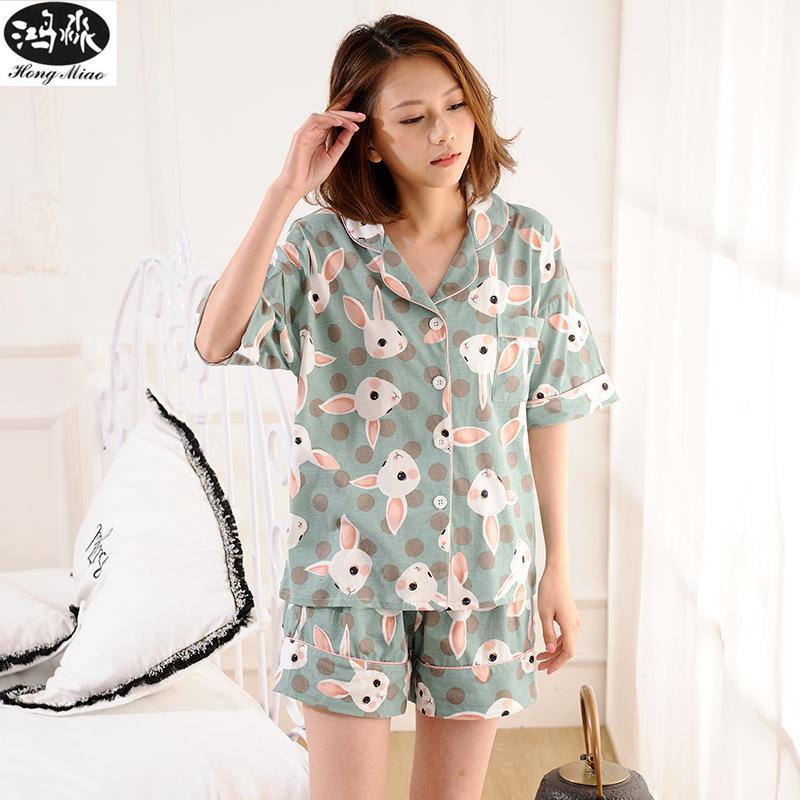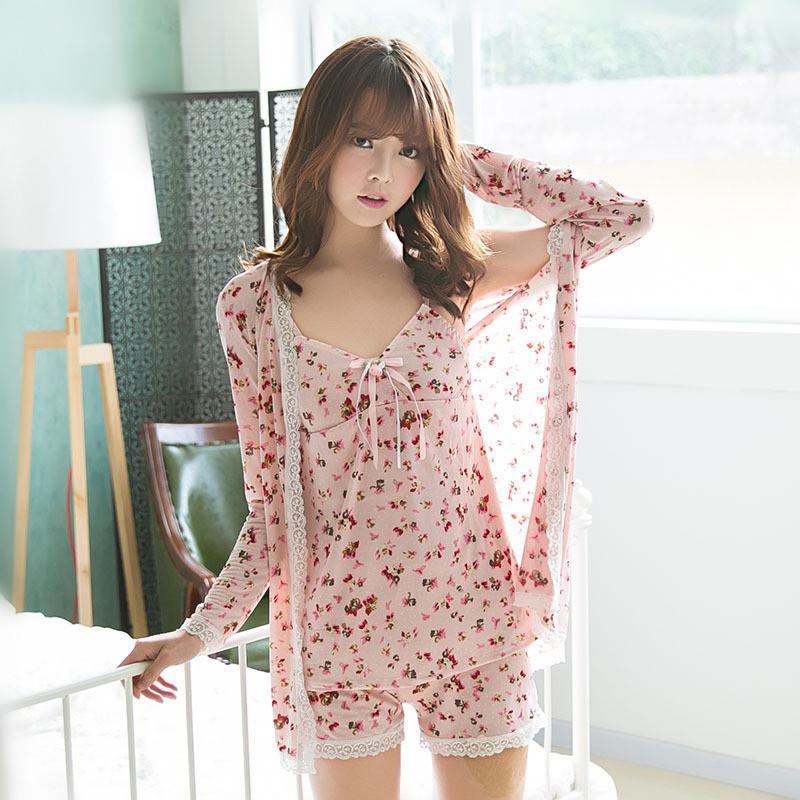The first image is the image on the left, the second image is the image on the right. Examine the images to the left and right. Is the description "A model wears a pajama shorts set patterned all over with cute animals." accurate? Answer yes or no. Yes. The first image is the image on the left, the second image is the image on the right. Examine the images to the left and right. Is the description "There is a lamp behind a girl wearing pajamas." accurate? Answer yes or no. Yes. 